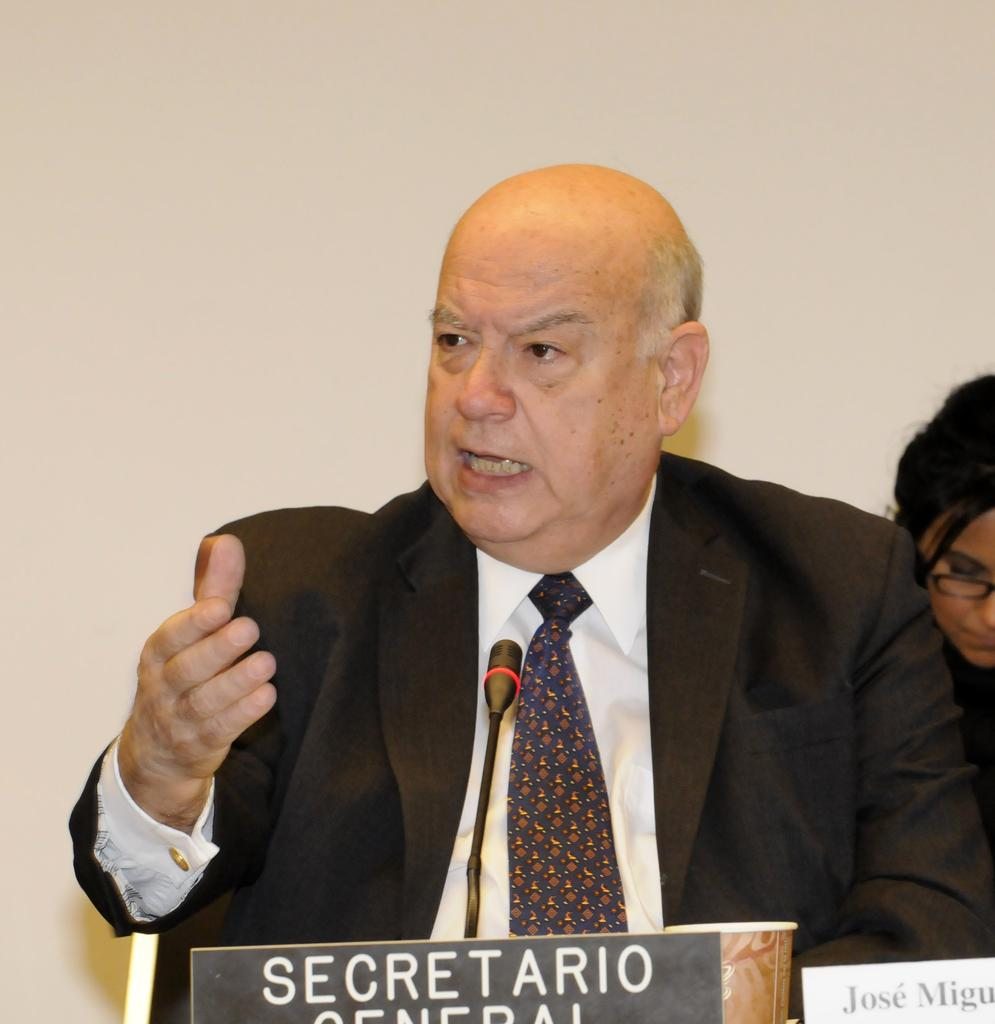What is the man in the image doing? The man in the image is talking. What is in front of the man to aid his communication? There is a microphone in front of the man. What can be seen on the table in front of the man? There are name boards and a cup in front of the man. Can you describe the background of the image? There is a person visible in the background of the image, and there is a wall in the background. What type of boat can be seen in the image? There is no boat present in the image. How many wings are visible in the image? There are no wings visible in the image. 